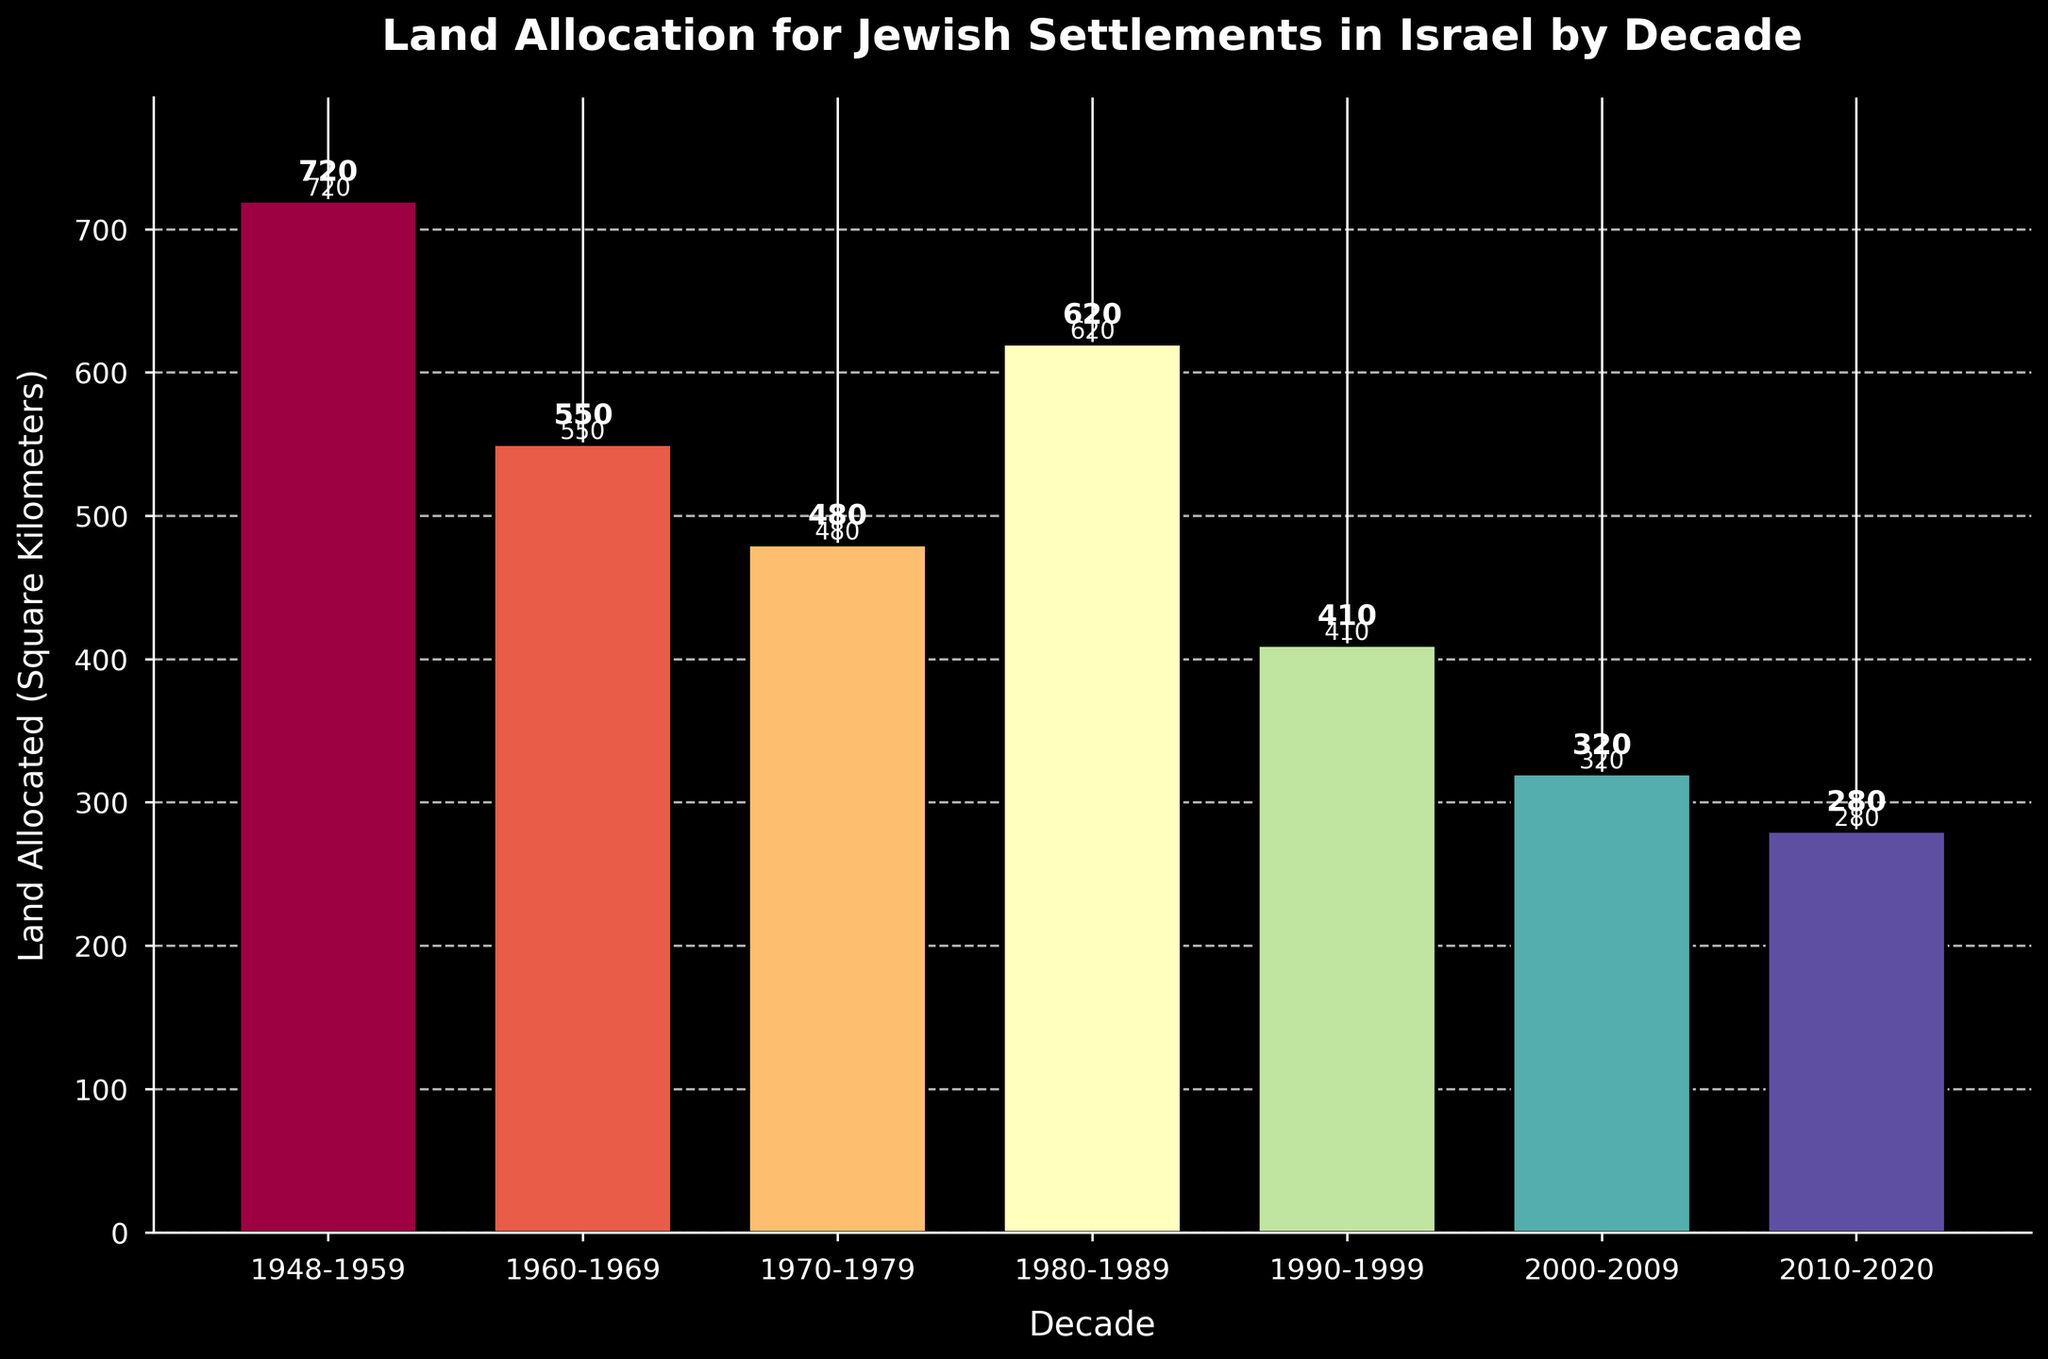What was the total land allocated for Jewish settlements between 1948 and 1989? To find the total land allocation between 1948 and 1989, sum the values for each decade: 720 (1948-1959) + 550 (1960-1969) + 480 (1970-1979) + 620 (1980-1989) = 2370 square kilometers.
Answer: 2370 square kilometers How much more land was allocated in the decade 1948-1959 compared to 2010-2020? Subtract the land allocation for 2010-2020 (280) from that of 1948-1959 (720): 720 - 280 = 440 square kilometers.
Answer: 440 square kilometers Which decade had the highest land allocation? By visually inspecting the height of the bars, the decade 1948-1959 had the highest land allocation with 720 square kilometers.
Answer: 1948-1959 Which decade had the lowest land allocation and what was the value? By visually inspecting the bars, the decade 2010-2020 had the lowest allocation with 280 square kilometers.
Answer: 2010-2020, 280 square kilometers Was there a consistent decrease in land allocation over the decades? No, the land allocation fluctuated: decreased from 1948-1959 to 1970-1979, increased in 1980-1989, then consistently decreased from 1990-1999 to 2010-2020.
Answer: No What is the average land allocation per decade from 1948 to 2020? Sum the land allocations of all decades and divide by the number of decades: (720 + 550 + 480 + 620 + 410 + 320 + 280) / 7 = 3380 / 7 ≈ 483 square kilometers.
Answer: 483 square kilometers How much land was allocated in the 1980-1989 decade relative to the 1990-1999 decade? The land allocation in 1980-1989 (620) compared to 1990-1999 (410), the difference is 620 - 410 = 210 square kilometers.
Answer: 210 square kilometers Which color is associated with the decade 1970-1979 for visual differentiation? By inspecting the colors of the bars, approximately from the color gradient, the decade 1970-1979 uses a mid-spectrum color from the Spectral colormap, likely yellow-green.
Answer: Yellow-Green How did land allocation in the 2000-2009 decade compare to the following decade, 2010-2020? Allocate 320 square kilometers in 2000-2009 and 280 square kilometers in 2010-2020, showing that it decreased by 40 square kilometers: 320 - 280 = 40.
Answer: Decreased by 40 square kilometers What proportion of the total land allocated from 1948-2020 was allocated in the first two decades? First, find the total land allocation for the periods and sum: 720 (1948-1959) + 550 (1960-1969) = 1270. Next, sum all the decades: 3380. The proportion is 1270/3380 ≈ 0.376 or 37.6%.
Answer: 37.6% 